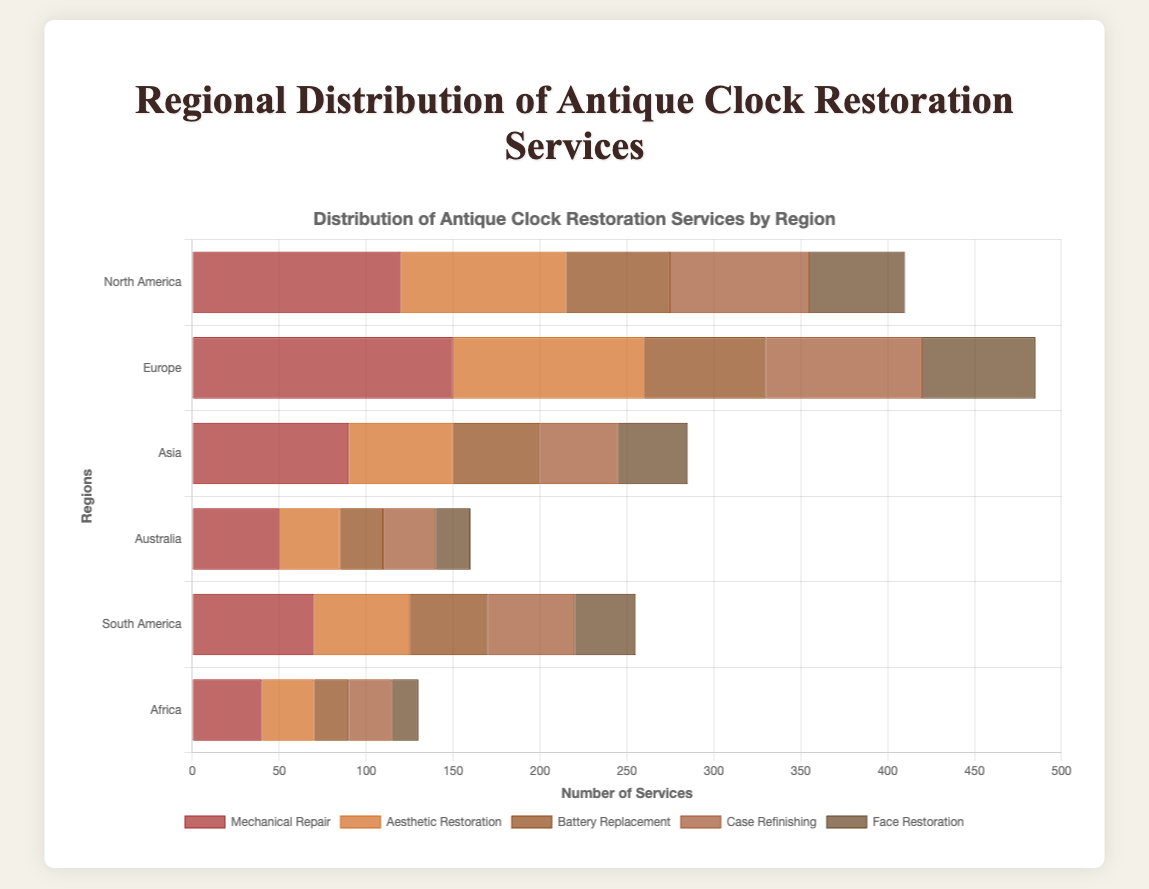What region has the highest number of mechanical repair services? By observing the length of the bars for mechanical repair services across all regions, Europe has the longest bar, indicating the highest number of such services.
Answer: Europe What is the total number of services offered in Asia? Add up all the services in the Asia region: Mechanical Repair (90) + Aesthetic Restoration (60) + Battery Replacement (50) + Case Refinishing (45) + Face Restoration (40) = 285
Answer: 285 Which region has the least number of face restoration services? By comparing the lengths of the bars representing face restoration services, Africa has the shortest bar, indicating the fewest face restoration services.
Answer: Africa Which service type has the highest number in South America? By comparing the lengths of all service type bars in South America, Mechanical Repair has the longest bar.
Answer: Mechanical Repair Compare the total services between North America and Australia. Which one offers more? Calculate the sum of services for both regions. North America: 120 + 95 + 60 + 80 + 55 = 410; Australia: 50 + 35 + 25 + 30 + 20 = 160. North America offers more services.
Answer: North America What is the average number of aesthetic restoration services across all regions? Sum all the aesthetic restoration services and divide by the number of regions: (95 + 110 + 60 + 35 + 55 + 30) / 6 = 64.16667, approximately 64.17
Answer: 64.17 Which region has more battery replacement services, North America or Asia? Compare the bars representing battery replacement services. North America has 60, while Asia has 50 battery replacement services. Hence, North America has more.
Answer: North America Which type of service has the least total number across all regions? Summing up each service type across all regions reveals that Face Restoration has the smallest total: (55 + 65 + 40 + 20 + 35 + 15) = 230
Answer: Face Restoration How does the number of case refinishing services in Europe compare to South America? Comparing the bar lengths for case refinishing services, Europe has 90, while South America has 50. Europe has more case refinishing services.
Answer: Europe How many more aesthetic restoration services are provided in Europe compared to Africa? Subtract the number of aesthetic restoration services in Africa from Europe: 110 - 30 = 80 more services in Europe.
Answer: 80 